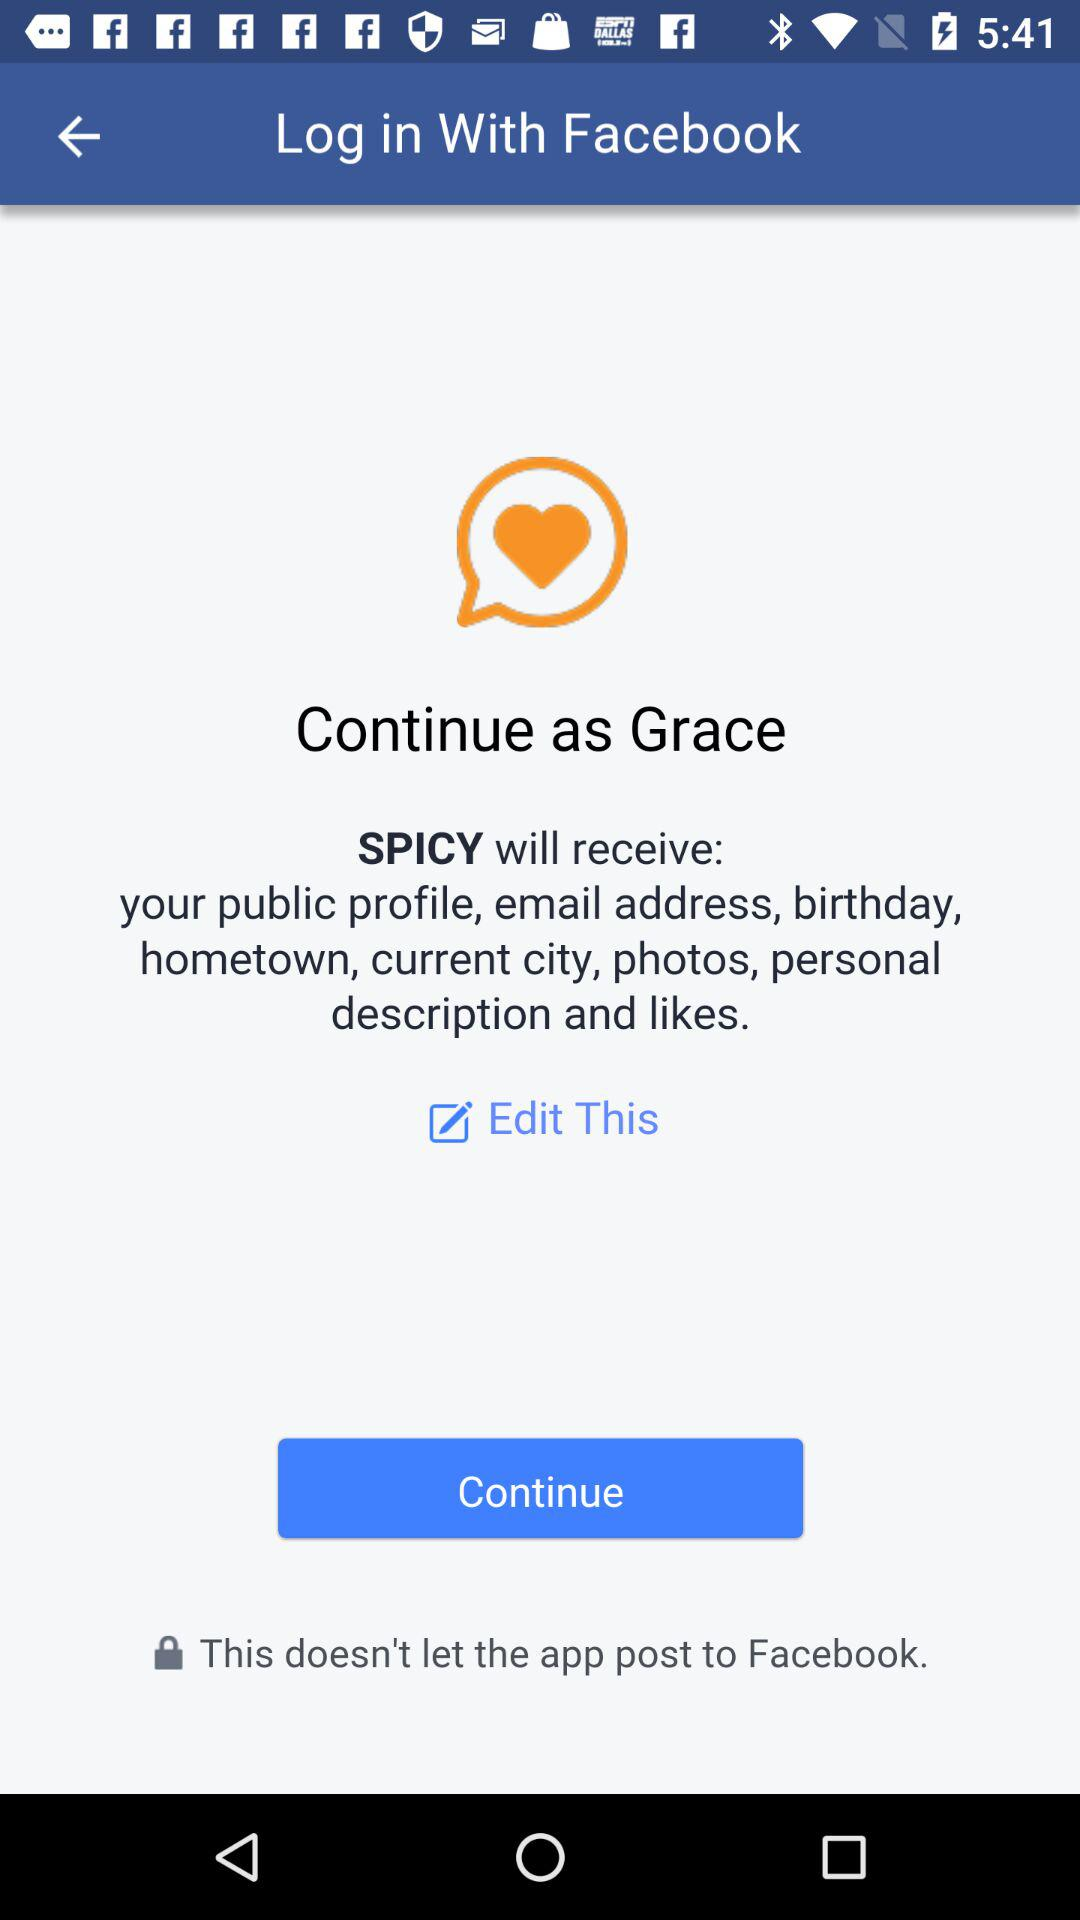What app can we use to continue? The app is "SPICY". 